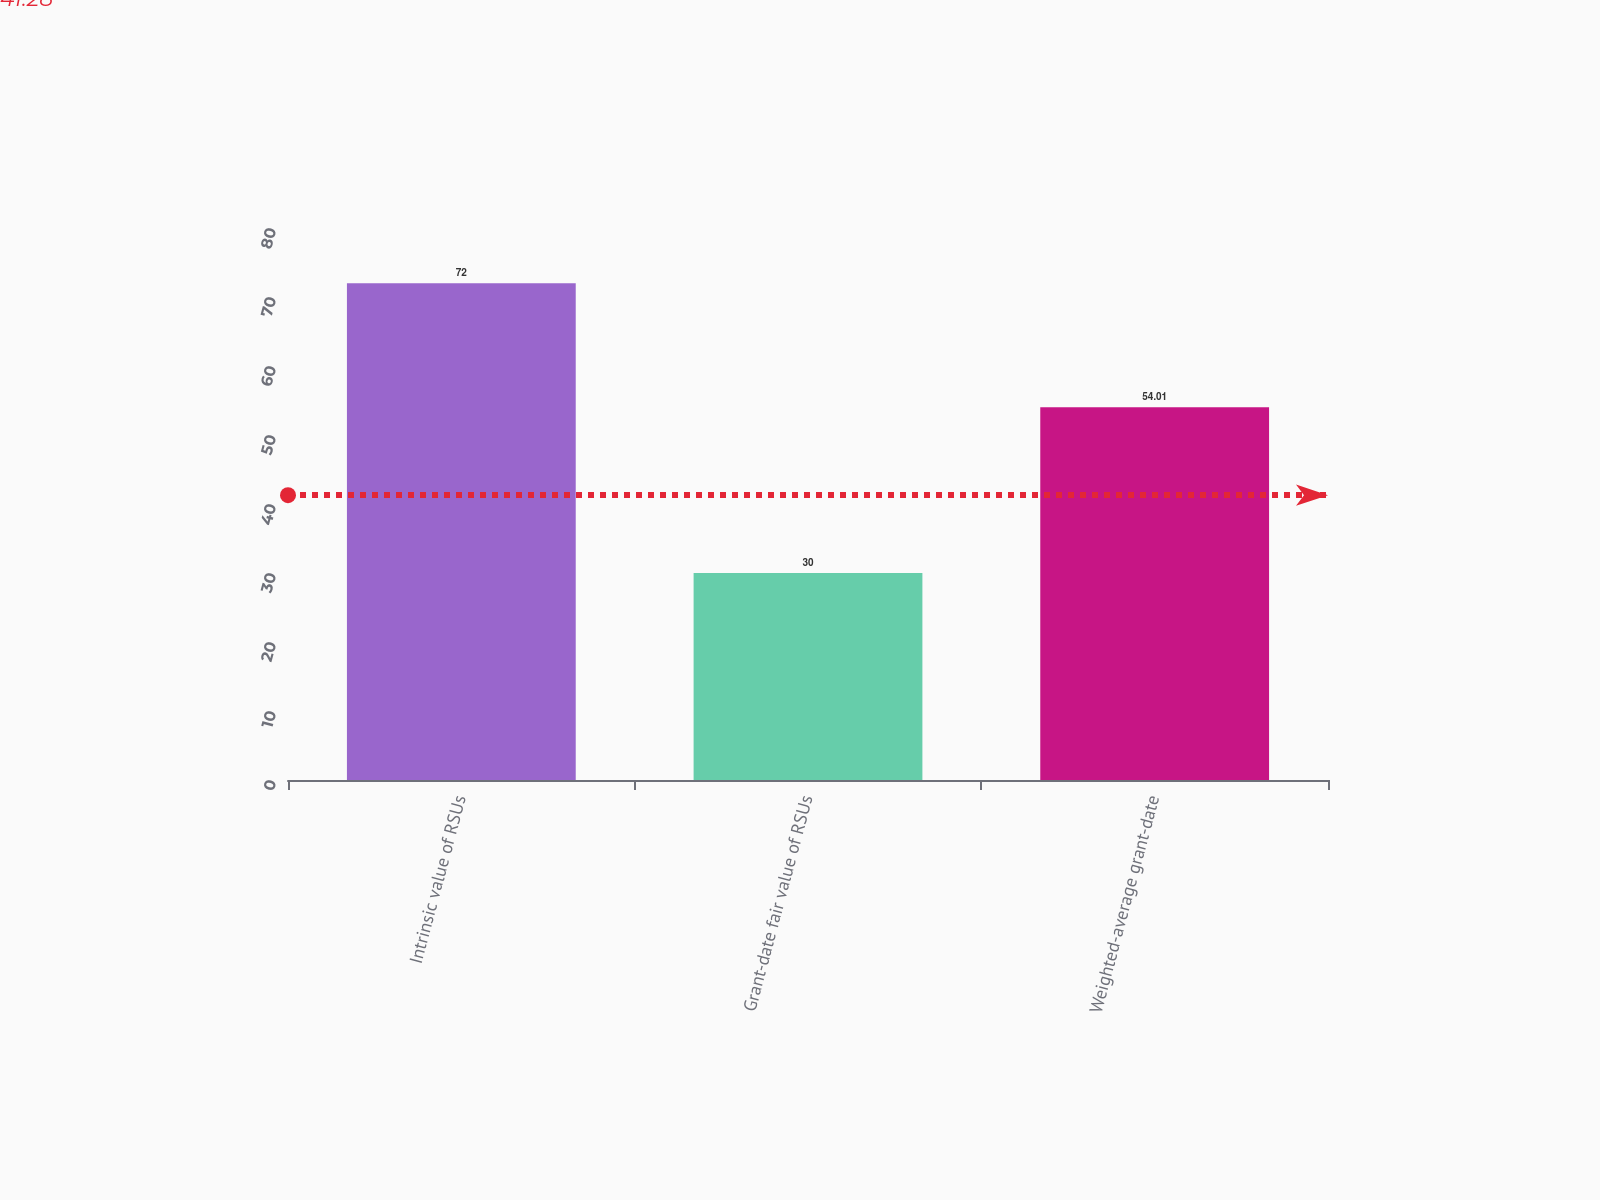Convert chart. <chart><loc_0><loc_0><loc_500><loc_500><bar_chart><fcel>Intrinsic value of RSUs<fcel>Grant-date fair value of RSUs<fcel>Weighted-average grant-date<nl><fcel>72<fcel>30<fcel>54.01<nl></chart> 